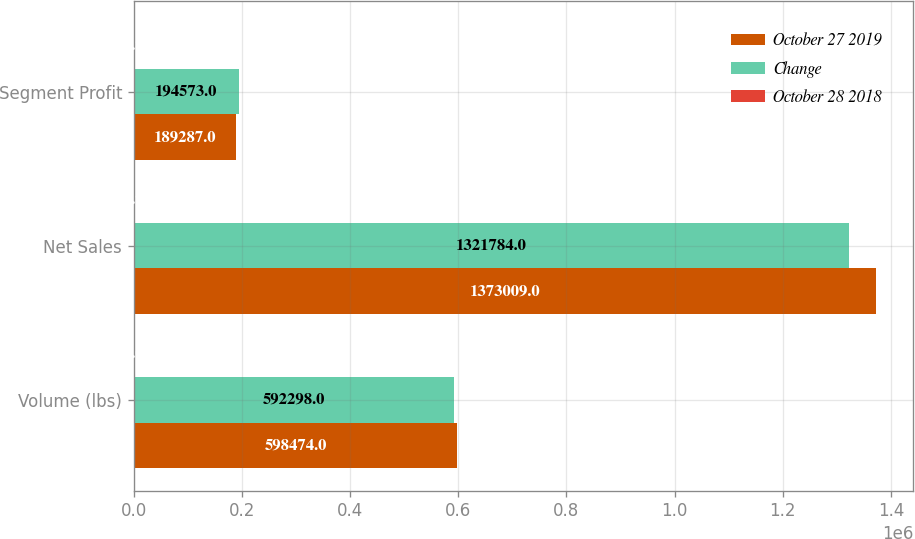Convert chart to OTSL. <chart><loc_0><loc_0><loc_500><loc_500><stacked_bar_chart><ecel><fcel>Volume (lbs)<fcel>Net Sales<fcel>Segment Profit<nl><fcel>October 27 2019<fcel>598474<fcel>1.37301e+06<fcel>189287<nl><fcel>Change<fcel>592298<fcel>1.32178e+06<fcel>194573<nl><fcel>October 28 2018<fcel>1<fcel>3.9<fcel>2.7<nl></chart> 